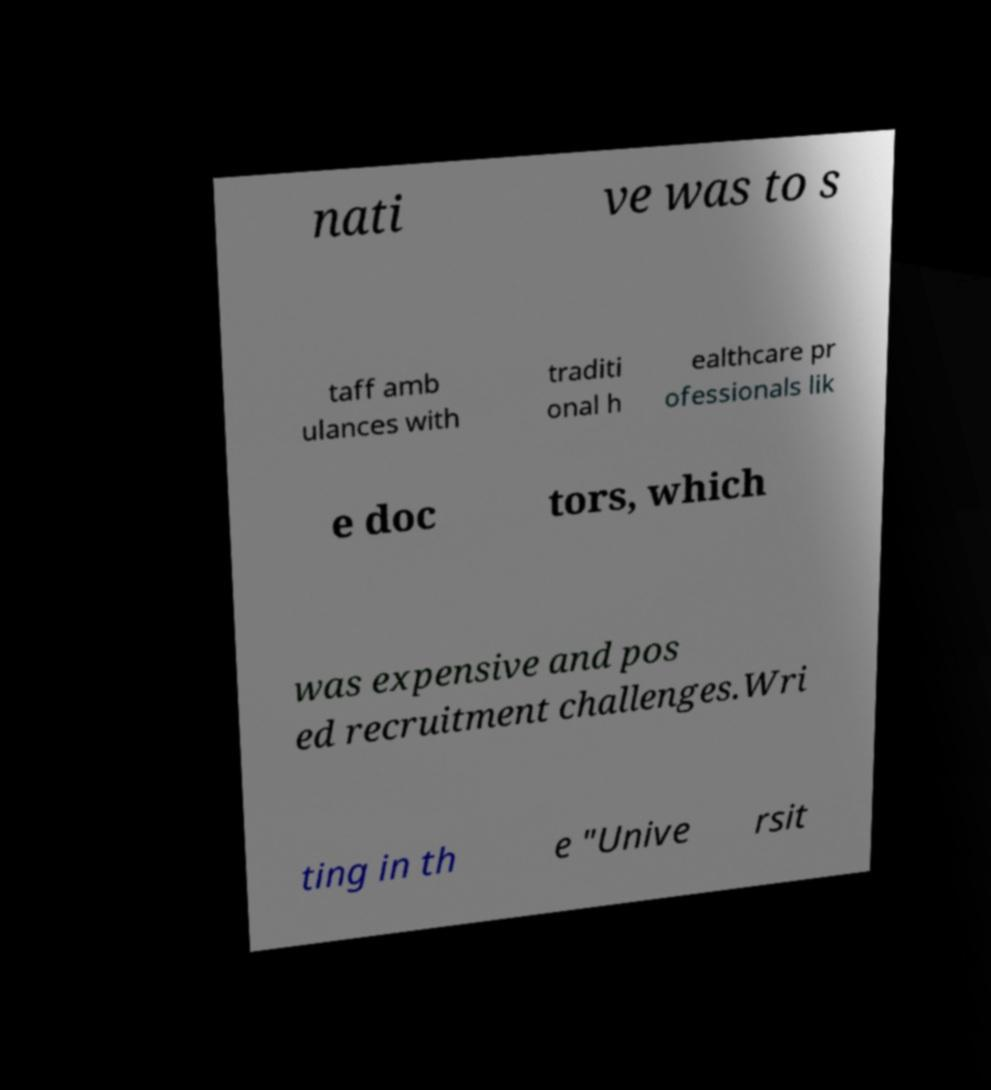I need the written content from this picture converted into text. Can you do that? nati ve was to s taff amb ulances with traditi onal h ealthcare pr ofessionals lik e doc tors, which was expensive and pos ed recruitment challenges.Wri ting in th e "Unive rsit 